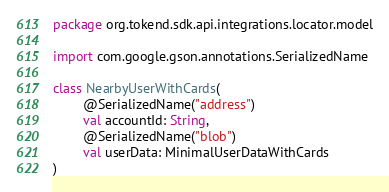<code> <loc_0><loc_0><loc_500><loc_500><_Kotlin_>package org.tokend.sdk.api.integrations.locator.model

import com.google.gson.annotations.SerializedName

class NearbyUserWithCards(
        @SerializedName("address")
        val accountId: String,
        @SerializedName("blob")
        val userData: MinimalUserDataWithCards
)</code> 